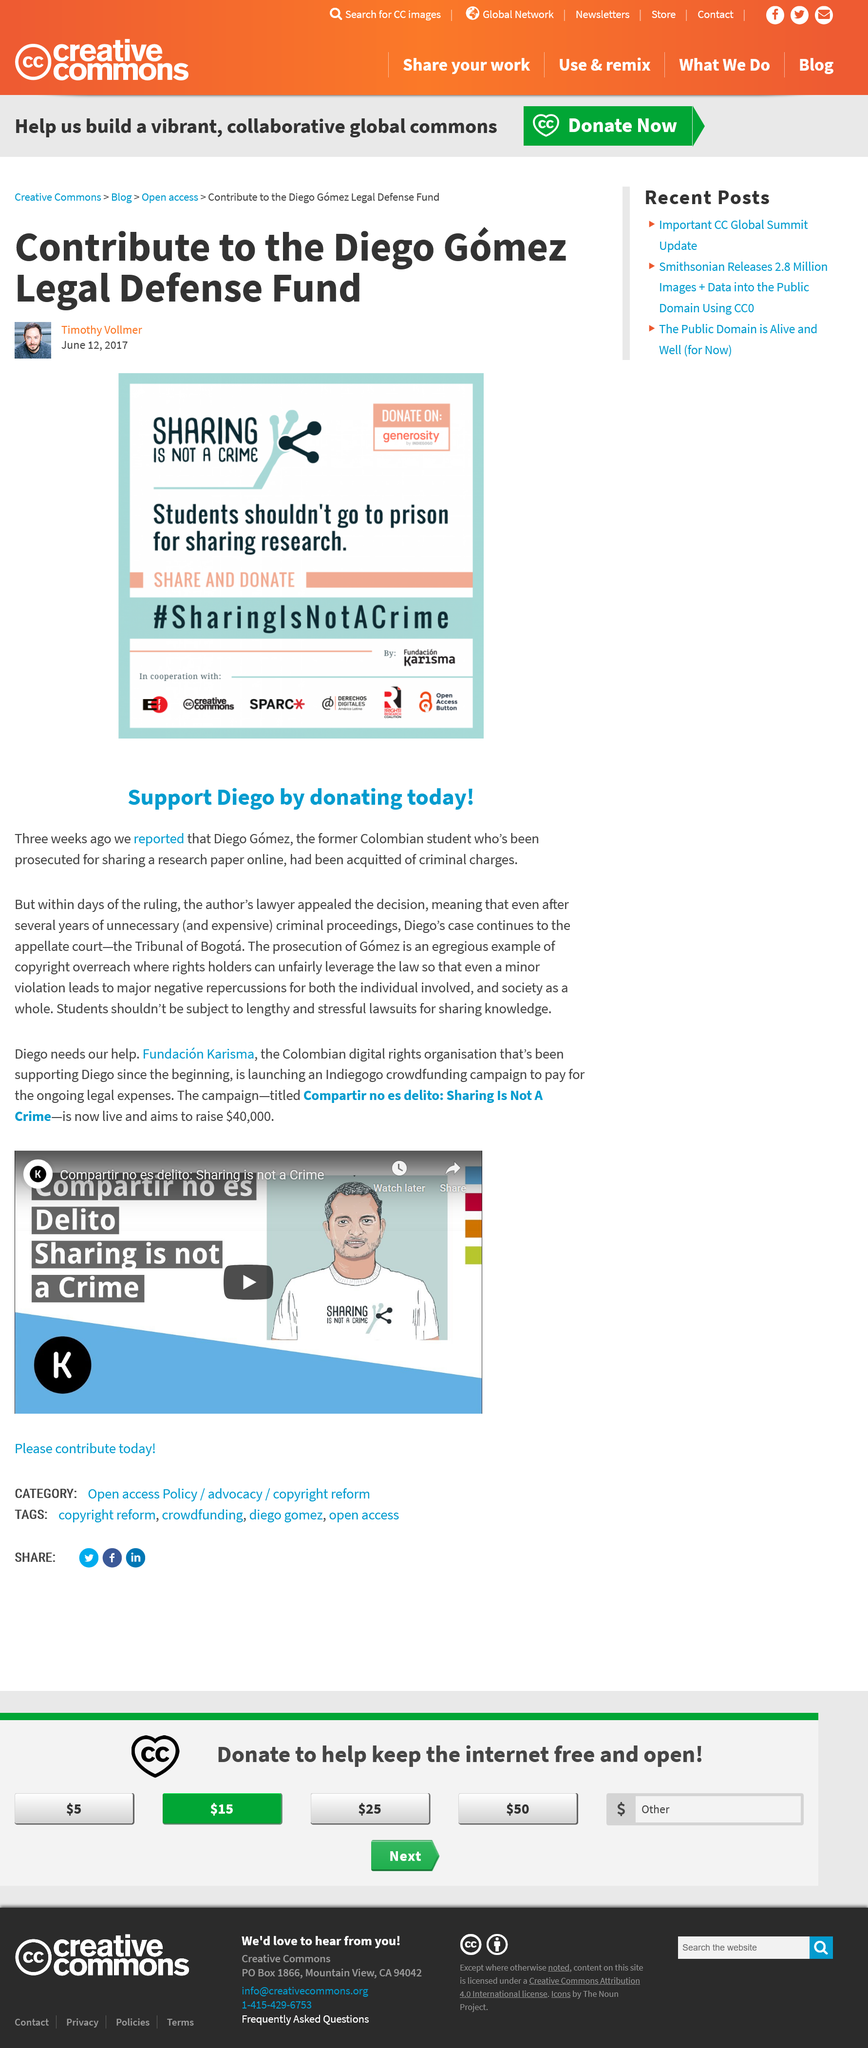Specify some key components in this picture. The Legal Defense Fund contributions are for Diego Gomez. Diego is being prosecuted for sharing a research paper online. The writer of the article is Timothy Vollmer. 